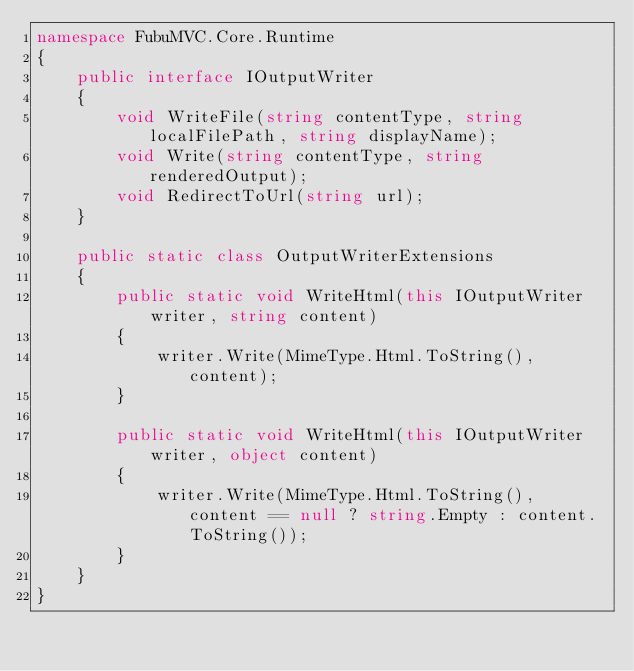<code> <loc_0><loc_0><loc_500><loc_500><_C#_>namespace FubuMVC.Core.Runtime
{
    public interface IOutputWriter
    {
        void WriteFile(string contentType, string localFilePath, string displayName);
        void Write(string contentType, string renderedOutput);
        void RedirectToUrl(string url);
    }

    public static class OutputWriterExtensions
    {
        public static void WriteHtml(this IOutputWriter writer, string content)
        {
            writer.Write(MimeType.Html.ToString(), content);
        }

        public static void WriteHtml(this IOutputWriter writer, object content)
        {
            writer.Write(MimeType.Html.ToString(), content == null ? string.Empty : content.ToString());
        }
    }
}</code> 